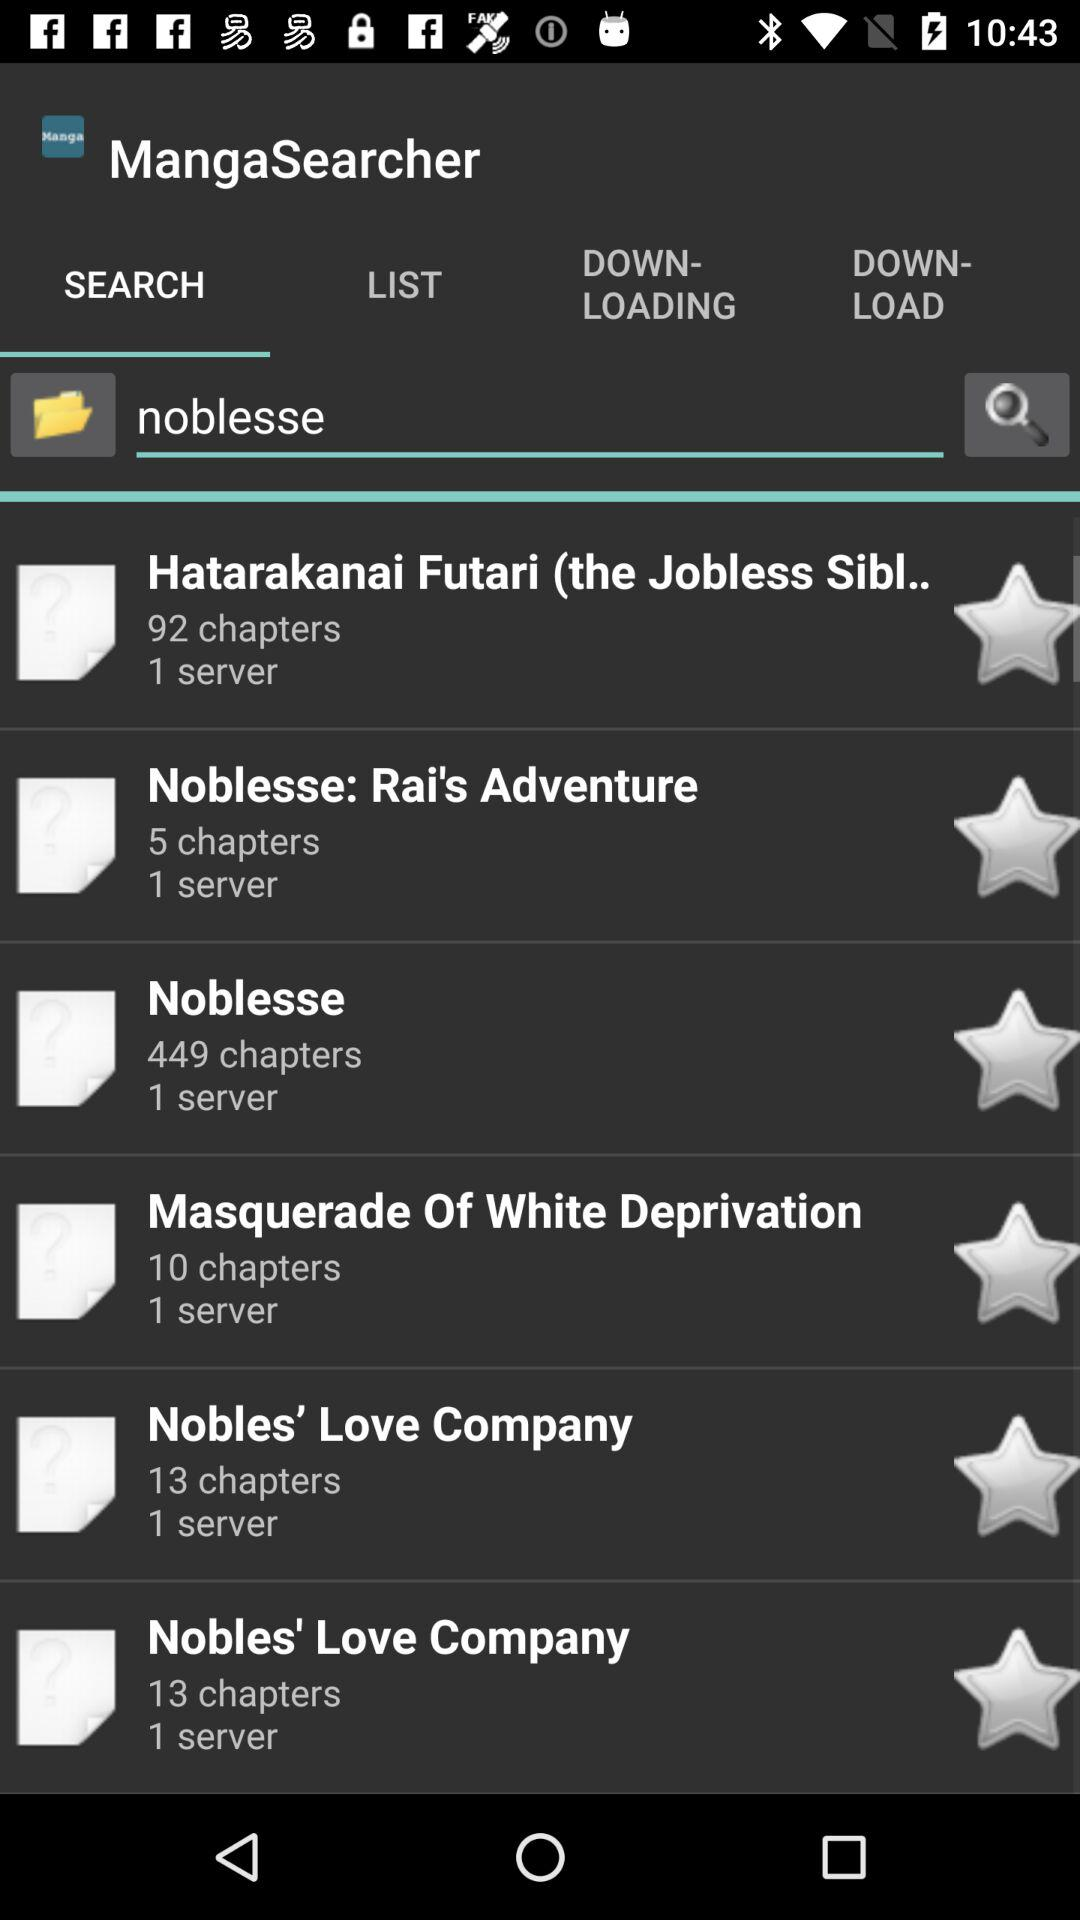What is the name of the application? The name of the application is "MangaSearcher". 